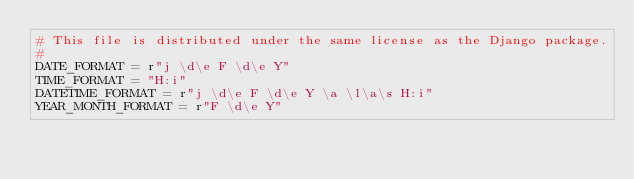<code> <loc_0><loc_0><loc_500><loc_500><_Python_># This file is distributed under the same license as the Django package.
#
DATE_FORMAT = r"j \d\e F \d\e Y"
TIME_FORMAT = "H:i"
DATETIME_FORMAT = r"j \d\e F \d\e Y \a \l\a\s H:i"
YEAR_MONTH_FORMAT = r"F \d\e Y"</code> 